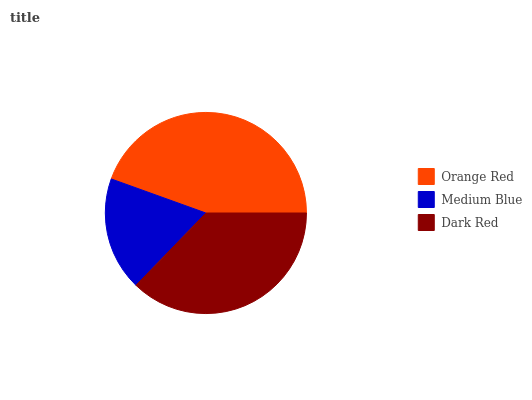Is Medium Blue the minimum?
Answer yes or no. Yes. Is Orange Red the maximum?
Answer yes or no. Yes. Is Dark Red the minimum?
Answer yes or no. No. Is Dark Red the maximum?
Answer yes or no. No. Is Dark Red greater than Medium Blue?
Answer yes or no. Yes. Is Medium Blue less than Dark Red?
Answer yes or no. Yes. Is Medium Blue greater than Dark Red?
Answer yes or no. No. Is Dark Red less than Medium Blue?
Answer yes or no. No. Is Dark Red the high median?
Answer yes or no. Yes. Is Dark Red the low median?
Answer yes or no. Yes. Is Medium Blue the high median?
Answer yes or no. No. Is Medium Blue the low median?
Answer yes or no. No. 